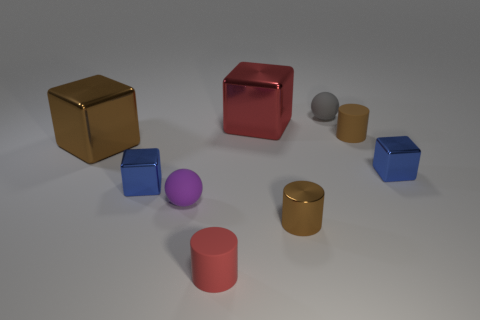Subtract all large brown shiny blocks. How many blocks are left? 3 Subtract all blue cubes. How many cubes are left? 2 Subtract 1 cylinders. How many cylinders are left? 2 Subtract all red balls. How many brown cylinders are left? 2 Subtract all cylinders. How many objects are left? 6 Subtract all brown cylinders. Subtract all gray blocks. How many cylinders are left? 1 Subtract all tiny brown shiny spheres. Subtract all brown matte cylinders. How many objects are left? 8 Add 3 tiny gray rubber objects. How many tiny gray rubber objects are left? 4 Add 4 small blue objects. How many small blue objects exist? 6 Subtract 0 cyan blocks. How many objects are left? 9 